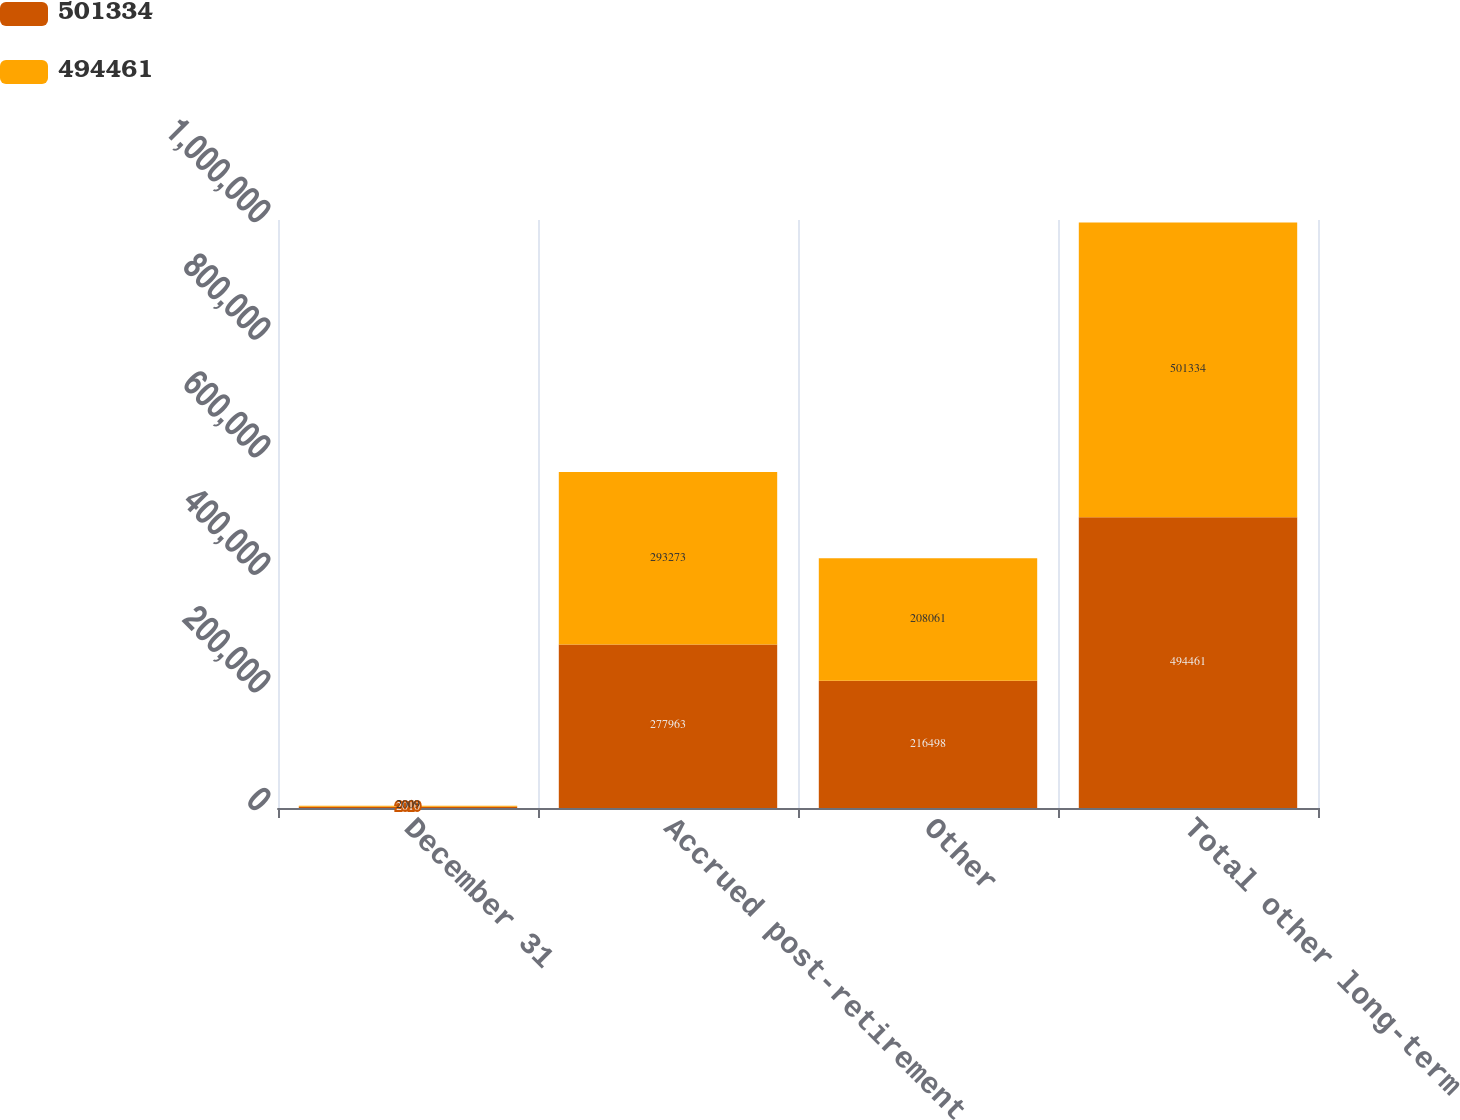Convert chart. <chart><loc_0><loc_0><loc_500><loc_500><stacked_bar_chart><ecel><fcel>December 31<fcel>Accrued post-retirement<fcel>Other<fcel>Total other long-term<nl><fcel>501334<fcel>2010<fcel>277963<fcel>216498<fcel>494461<nl><fcel>494461<fcel>2009<fcel>293273<fcel>208061<fcel>501334<nl></chart> 